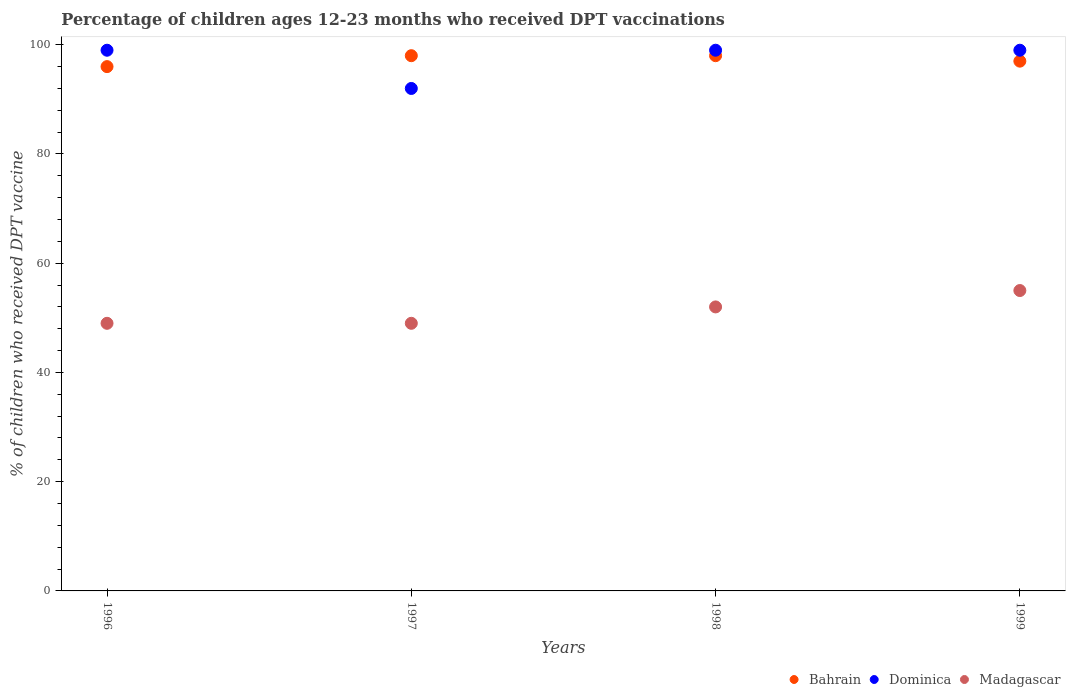How many different coloured dotlines are there?
Keep it short and to the point. 3. Is the number of dotlines equal to the number of legend labels?
Your response must be concise. Yes. Across all years, what is the maximum percentage of children who received DPT vaccination in Bahrain?
Your answer should be compact. 98. Across all years, what is the minimum percentage of children who received DPT vaccination in Dominica?
Provide a succinct answer. 92. In which year was the percentage of children who received DPT vaccination in Dominica maximum?
Your answer should be very brief. 1996. In which year was the percentage of children who received DPT vaccination in Madagascar minimum?
Offer a terse response. 1996. What is the total percentage of children who received DPT vaccination in Madagascar in the graph?
Your response must be concise. 205. What is the difference between the percentage of children who received DPT vaccination in Madagascar in 1997 and that in 1998?
Your answer should be very brief. -3. What is the difference between the percentage of children who received DPT vaccination in Bahrain in 1998 and the percentage of children who received DPT vaccination in Dominica in 1999?
Provide a succinct answer. -1. What is the average percentage of children who received DPT vaccination in Bahrain per year?
Provide a short and direct response. 97.25. In the year 1999, what is the difference between the percentage of children who received DPT vaccination in Dominica and percentage of children who received DPT vaccination in Bahrain?
Provide a short and direct response. 2. Is the percentage of children who received DPT vaccination in Dominica in 1997 less than that in 1998?
Provide a short and direct response. Yes. Is the difference between the percentage of children who received DPT vaccination in Dominica in 1997 and 1999 greater than the difference between the percentage of children who received DPT vaccination in Bahrain in 1997 and 1999?
Offer a terse response. No. What is the difference between the highest and the second highest percentage of children who received DPT vaccination in Bahrain?
Offer a terse response. 0. What is the difference between the highest and the lowest percentage of children who received DPT vaccination in Madagascar?
Offer a terse response. 6. Is the sum of the percentage of children who received DPT vaccination in Bahrain in 1997 and 1998 greater than the maximum percentage of children who received DPT vaccination in Madagascar across all years?
Keep it short and to the point. Yes. Is it the case that in every year, the sum of the percentage of children who received DPT vaccination in Bahrain and percentage of children who received DPT vaccination in Dominica  is greater than the percentage of children who received DPT vaccination in Madagascar?
Keep it short and to the point. Yes. Is the percentage of children who received DPT vaccination in Bahrain strictly greater than the percentage of children who received DPT vaccination in Dominica over the years?
Give a very brief answer. No. How many dotlines are there?
Your response must be concise. 3. How many years are there in the graph?
Offer a very short reply. 4. What is the difference between two consecutive major ticks on the Y-axis?
Your response must be concise. 20. Does the graph contain any zero values?
Keep it short and to the point. No. Does the graph contain grids?
Keep it short and to the point. No. What is the title of the graph?
Your response must be concise. Percentage of children ages 12-23 months who received DPT vaccinations. Does "Netherlands" appear as one of the legend labels in the graph?
Give a very brief answer. No. What is the label or title of the X-axis?
Provide a succinct answer. Years. What is the label or title of the Y-axis?
Give a very brief answer. % of children who received DPT vaccine. What is the % of children who received DPT vaccine in Bahrain in 1996?
Offer a terse response. 96. What is the % of children who received DPT vaccine in Dominica in 1996?
Your response must be concise. 99. What is the % of children who received DPT vaccine of Madagascar in 1996?
Your answer should be compact. 49. What is the % of children who received DPT vaccine in Bahrain in 1997?
Give a very brief answer. 98. What is the % of children who received DPT vaccine of Dominica in 1997?
Your response must be concise. 92. What is the % of children who received DPT vaccine in Madagascar in 1997?
Provide a short and direct response. 49. What is the % of children who received DPT vaccine of Madagascar in 1998?
Offer a very short reply. 52. What is the % of children who received DPT vaccine of Bahrain in 1999?
Make the answer very short. 97. What is the % of children who received DPT vaccine of Dominica in 1999?
Offer a very short reply. 99. What is the % of children who received DPT vaccine of Madagascar in 1999?
Make the answer very short. 55. Across all years, what is the maximum % of children who received DPT vaccine in Bahrain?
Your response must be concise. 98. Across all years, what is the maximum % of children who received DPT vaccine in Dominica?
Offer a very short reply. 99. Across all years, what is the maximum % of children who received DPT vaccine in Madagascar?
Make the answer very short. 55. Across all years, what is the minimum % of children who received DPT vaccine in Bahrain?
Provide a short and direct response. 96. Across all years, what is the minimum % of children who received DPT vaccine in Dominica?
Make the answer very short. 92. Across all years, what is the minimum % of children who received DPT vaccine in Madagascar?
Your response must be concise. 49. What is the total % of children who received DPT vaccine in Bahrain in the graph?
Offer a terse response. 389. What is the total % of children who received DPT vaccine of Dominica in the graph?
Your answer should be very brief. 389. What is the total % of children who received DPT vaccine in Madagascar in the graph?
Provide a short and direct response. 205. What is the difference between the % of children who received DPT vaccine in Madagascar in 1996 and that in 1998?
Your answer should be very brief. -3. What is the difference between the % of children who received DPT vaccine in Dominica in 1996 and that in 1999?
Make the answer very short. 0. What is the difference between the % of children who received DPT vaccine in Madagascar in 1996 and that in 1999?
Your response must be concise. -6. What is the difference between the % of children who received DPT vaccine of Dominica in 1997 and that in 1998?
Provide a short and direct response. -7. What is the difference between the % of children who received DPT vaccine of Madagascar in 1997 and that in 1999?
Offer a very short reply. -6. What is the difference between the % of children who received DPT vaccine in Bahrain in 1998 and that in 1999?
Offer a very short reply. 1. What is the difference between the % of children who received DPT vaccine of Bahrain in 1996 and the % of children who received DPT vaccine of Madagascar in 1997?
Ensure brevity in your answer.  47. What is the difference between the % of children who received DPT vaccine of Bahrain in 1996 and the % of children who received DPT vaccine of Madagascar in 1998?
Provide a succinct answer. 44. What is the difference between the % of children who received DPT vaccine in Dominica in 1996 and the % of children who received DPT vaccine in Madagascar in 1999?
Your response must be concise. 44. What is the difference between the % of children who received DPT vaccine in Dominica in 1997 and the % of children who received DPT vaccine in Madagascar in 1998?
Make the answer very short. 40. What is the difference between the % of children who received DPT vaccine in Dominica in 1997 and the % of children who received DPT vaccine in Madagascar in 1999?
Make the answer very short. 37. What is the difference between the % of children who received DPT vaccine in Bahrain in 1998 and the % of children who received DPT vaccine in Madagascar in 1999?
Offer a terse response. 43. What is the average % of children who received DPT vaccine of Bahrain per year?
Your answer should be compact. 97.25. What is the average % of children who received DPT vaccine in Dominica per year?
Offer a terse response. 97.25. What is the average % of children who received DPT vaccine of Madagascar per year?
Keep it short and to the point. 51.25. In the year 1996, what is the difference between the % of children who received DPT vaccine of Bahrain and % of children who received DPT vaccine of Dominica?
Ensure brevity in your answer.  -3. In the year 1996, what is the difference between the % of children who received DPT vaccine of Bahrain and % of children who received DPT vaccine of Madagascar?
Offer a very short reply. 47. In the year 1996, what is the difference between the % of children who received DPT vaccine of Dominica and % of children who received DPT vaccine of Madagascar?
Your answer should be compact. 50. In the year 1997, what is the difference between the % of children who received DPT vaccine of Bahrain and % of children who received DPT vaccine of Dominica?
Give a very brief answer. 6. In the year 1998, what is the difference between the % of children who received DPT vaccine of Dominica and % of children who received DPT vaccine of Madagascar?
Your response must be concise. 47. In the year 1999, what is the difference between the % of children who received DPT vaccine in Bahrain and % of children who received DPT vaccine in Dominica?
Ensure brevity in your answer.  -2. What is the ratio of the % of children who received DPT vaccine in Bahrain in 1996 to that in 1997?
Give a very brief answer. 0.98. What is the ratio of the % of children who received DPT vaccine of Dominica in 1996 to that in 1997?
Offer a very short reply. 1.08. What is the ratio of the % of children who received DPT vaccine in Bahrain in 1996 to that in 1998?
Your answer should be compact. 0.98. What is the ratio of the % of children who received DPT vaccine in Dominica in 1996 to that in 1998?
Your response must be concise. 1. What is the ratio of the % of children who received DPT vaccine in Madagascar in 1996 to that in 1998?
Offer a very short reply. 0.94. What is the ratio of the % of children who received DPT vaccine in Madagascar in 1996 to that in 1999?
Your response must be concise. 0.89. What is the ratio of the % of children who received DPT vaccine of Dominica in 1997 to that in 1998?
Your answer should be very brief. 0.93. What is the ratio of the % of children who received DPT vaccine in Madagascar in 1997 to that in 1998?
Offer a terse response. 0.94. What is the ratio of the % of children who received DPT vaccine in Bahrain in 1997 to that in 1999?
Keep it short and to the point. 1.01. What is the ratio of the % of children who received DPT vaccine in Dominica in 1997 to that in 1999?
Ensure brevity in your answer.  0.93. What is the ratio of the % of children who received DPT vaccine in Madagascar in 1997 to that in 1999?
Your response must be concise. 0.89. What is the ratio of the % of children who received DPT vaccine in Bahrain in 1998 to that in 1999?
Provide a short and direct response. 1.01. What is the ratio of the % of children who received DPT vaccine of Dominica in 1998 to that in 1999?
Offer a terse response. 1. What is the ratio of the % of children who received DPT vaccine of Madagascar in 1998 to that in 1999?
Offer a very short reply. 0.95. What is the difference between the highest and the second highest % of children who received DPT vaccine in Dominica?
Give a very brief answer. 0. What is the difference between the highest and the lowest % of children who received DPT vaccine of Dominica?
Keep it short and to the point. 7. What is the difference between the highest and the lowest % of children who received DPT vaccine of Madagascar?
Provide a succinct answer. 6. 